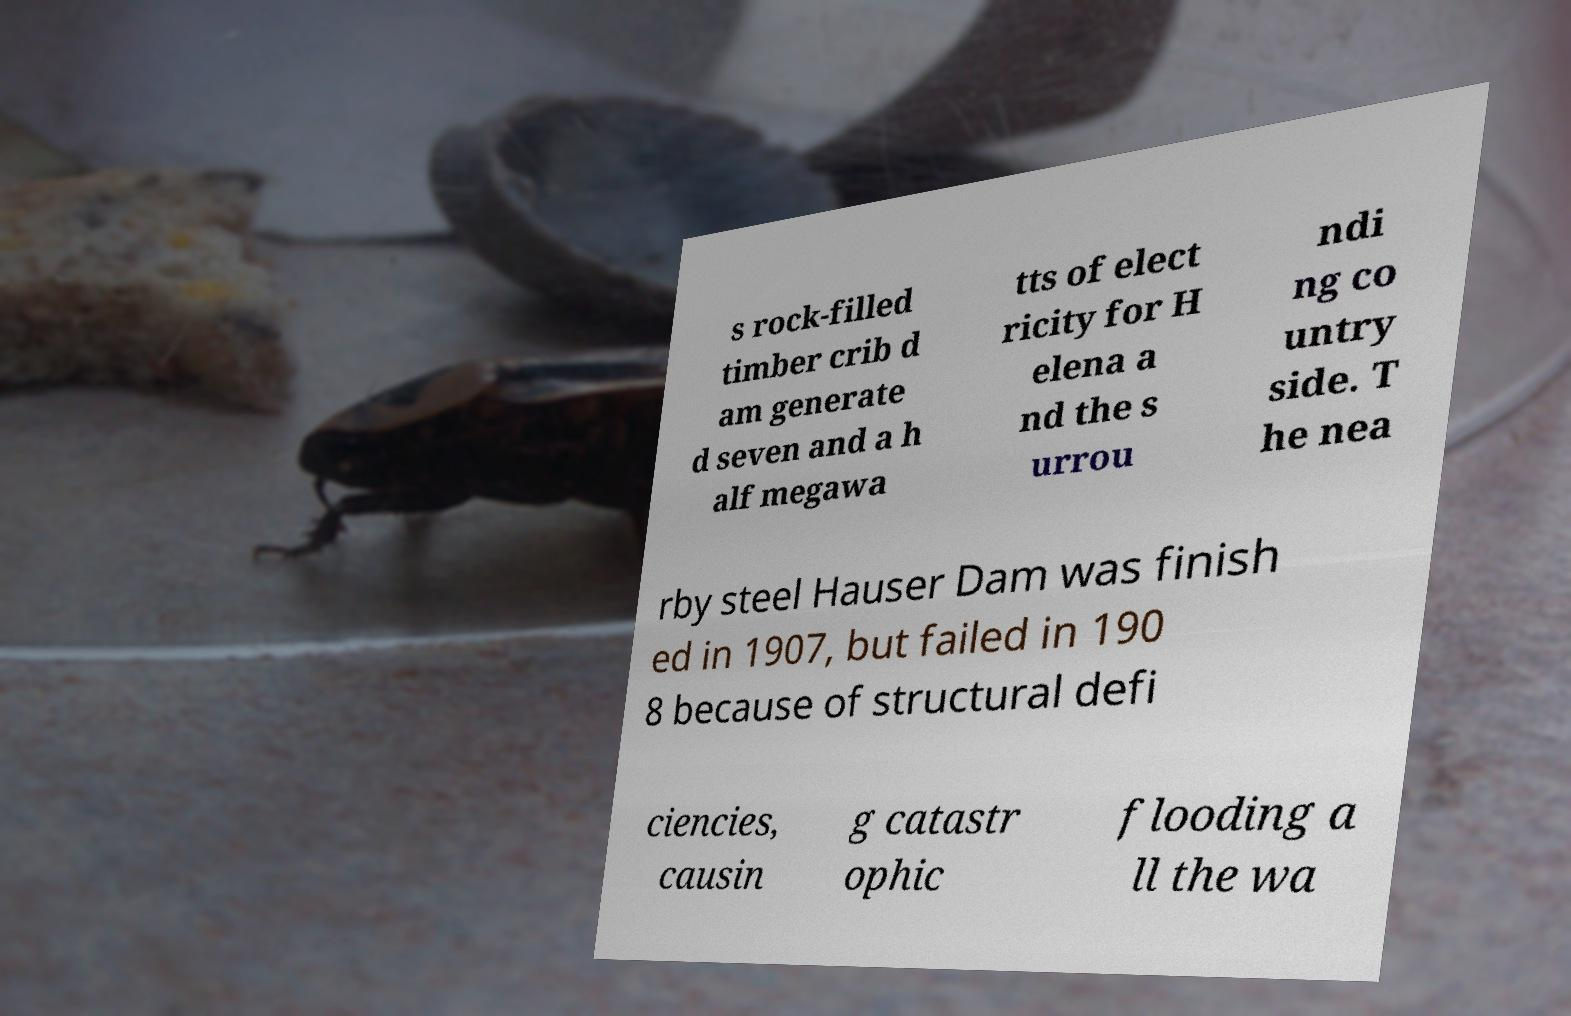Could you assist in decoding the text presented in this image and type it out clearly? s rock-filled timber crib d am generate d seven and a h alf megawa tts of elect ricity for H elena a nd the s urrou ndi ng co untry side. T he nea rby steel Hauser Dam was finish ed in 1907, but failed in 190 8 because of structural defi ciencies, causin g catastr ophic flooding a ll the wa 